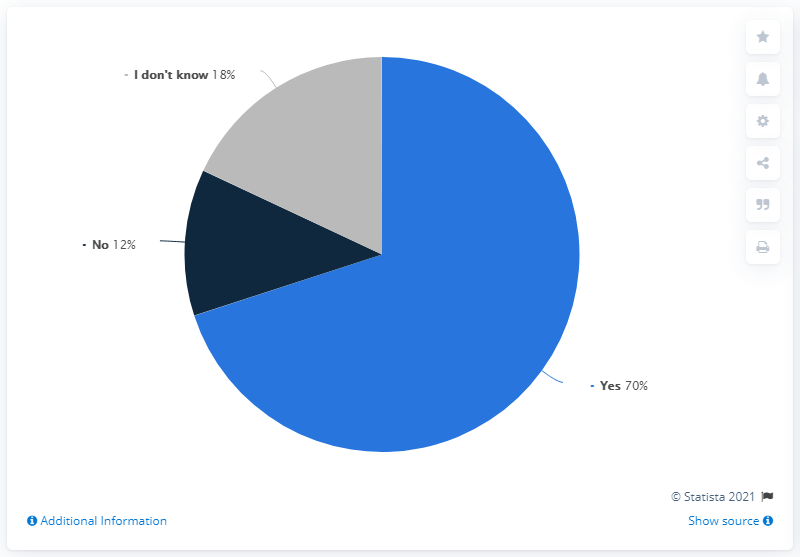Point out several critical features in this image. I am uncertain, what does grey indicate? The sum of 30 except for "yes" is 30. 